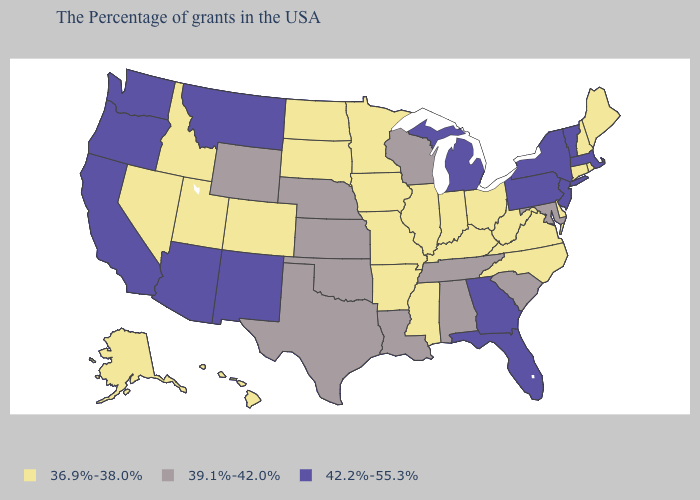Name the states that have a value in the range 36.9%-38.0%?
Concise answer only. Maine, Rhode Island, New Hampshire, Connecticut, Delaware, Virginia, North Carolina, West Virginia, Ohio, Kentucky, Indiana, Illinois, Mississippi, Missouri, Arkansas, Minnesota, Iowa, South Dakota, North Dakota, Colorado, Utah, Idaho, Nevada, Alaska, Hawaii. Does Montana have the highest value in the USA?
Answer briefly. Yes. What is the lowest value in the USA?
Give a very brief answer. 36.9%-38.0%. What is the value of Ohio?
Give a very brief answer. 36.9%-38.0%. Name the states that have a value in the range 36.9%-38.0%?
Keep it brief. Maine, Rhode Island, New Hampshire, Connecticut, Delaware, Virginia, North Carolina, West Virginia, Ohio, Kentucky, Indiana, Illinois, Mississippi, Missouri, Arkansas, Minnesota, Iowa, South Dakota, North Dakota, Colorado, Utah, Idaho, Nevada, Alaska, Hawaii. Which states have the lowest value in the USA?
Keep it brief. Maine, Rhode Island, New Hampshire, Connecticut, Delaware, Virginia, North Carolina, West Virginia, Ohio, Kentucky, Indiana, Illinois, Mississippi, Missouri, Arkansas, Minnesota, Iowa, South Dakota, North Dakota, Colorado, Utah, Idaho, Nevada, Alaska, Hawaii. Does Nevada have the highest value in the USA?
Keep it brief. No. What is the lowest value in the Northeast?
Keep it brief. 36.9%-38.0%. Is the legend a continuous bar?
Keep it brief. No. Among the states that border Nevada , which have the lowest value?
Give a very brief answer. Utah, Idaho. Which states hav the highest value in the South?
Be succinct. Florida, Georgia. What is the lowest value in states that border Connecticut?
Concise answer only. 36.9%-38.0%. Does the map have missing data?
Answer briefly. No. Does Wisconsin have a higher value than North Carolina?
Quick response, please. Yes. Name the states that have a value in the range 42.2%-55.3%?
Quick response, please. Massachusetts, Vermont, New York, New Jersey, Pennsylvania, Florida, Georgia, Michigan, New Mexico, Montana, Arizona, California, Washington, Oregon. 